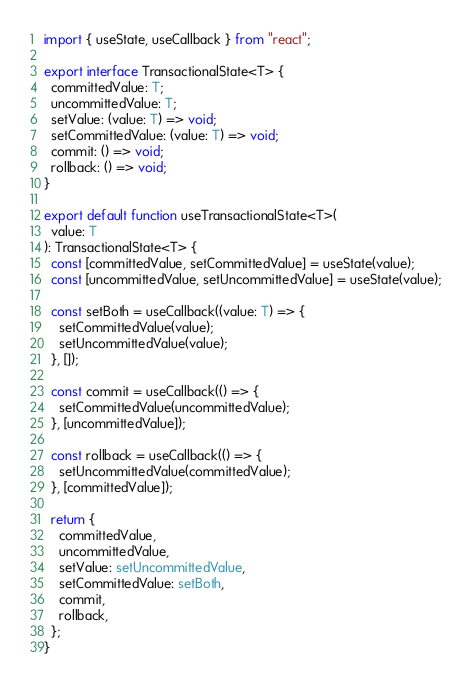Convert code to text. <code><loc_0><loc_0><loc_500><loc_500><_TypeScript_>import { useState, useCallback } from "react";

export interface TransactionalState<T> {
  committedValue: T;
  uncommittedValue: T;
  setValue: (value: T) => void;
  setCommittedValue: (value: T) => void;
  commit: () => void;
  rollback: () => void;
}

export default function useTransactionalState<T>(
  value: T
): TransactionalState<T> {
  const [committedValue, setCommittedValue] = useState(value);
  const [uncommittedValue, setUncommittedValue] = useState(value);

  const setBoth = useCallback((value: T) => {
    setCommittedValue(value);
    setUncommittedValue(value);
  }, []);

  const commit = useCallback(() => {
    setCommittedValue(uncommittedValue);
  }, [uncommittedValue]);

  const rollback = useCallback(() => {
    setUncommittedValue(committedValue);
  }, [committedValue]);

  return {
    committedValue,
    uncommittedValue,
    setValue: setUncommittedValue,
    setCommittedValue: setBoth,
    commit,
    rollback,
  };
}
</code> 